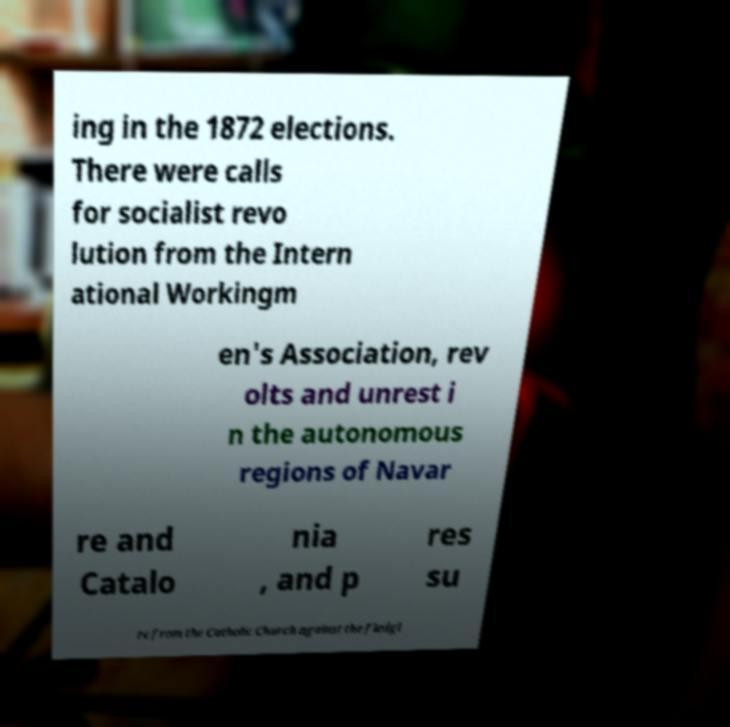Can you accurately transcribe the text from the provided image for me? ing in the 1872 elections. There were calls for socialist revo lution from the Intern ational Workingm en's Association, rev olts and unrest i n the autonomous regions of Navar re and Catalo nia , and p res su re from the Catholic Church against the fledgl 